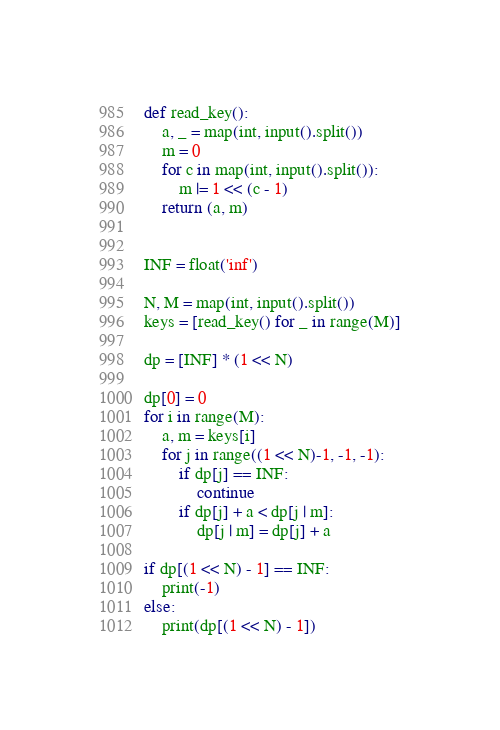<code> <loc_0><loc_0><loc_500><loc_500><_Python_>def read_key():
    a, _ = map(int, input().split())
    m = 0
    for c in map(int, input().split()):
        m |= 1 << (c - 1)
    return (a, m)


INF = float('inf')

N, M = map(int, input().split())
keys = [read_key() for _ in range(M)]

dp = [INF] * (1 << N)

dp[0] = 0
for i in range(M):
    a, m = keys[i]
    for j in range((1 << N)-1, -1, -1):
        if dp[j] == INF:
            continue
        if dp[j] + a < dp[j | m]:
            dp[j | m] = dp[j] + a

if dp[(1 << N) - 1] == INF:
    print(-1)
else:
    print(dp[(1 << N) - 1])
</code> 